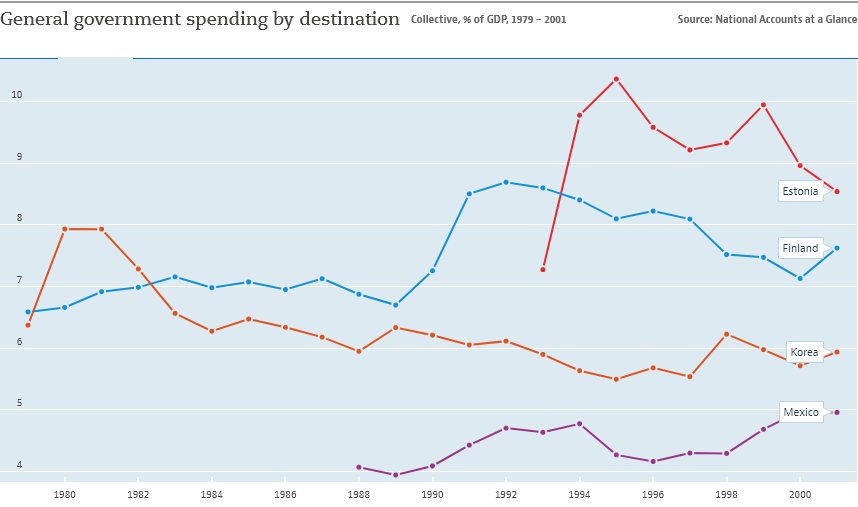Outline some significant characteristics in this image. Finland is the country represented by the blue color line. 